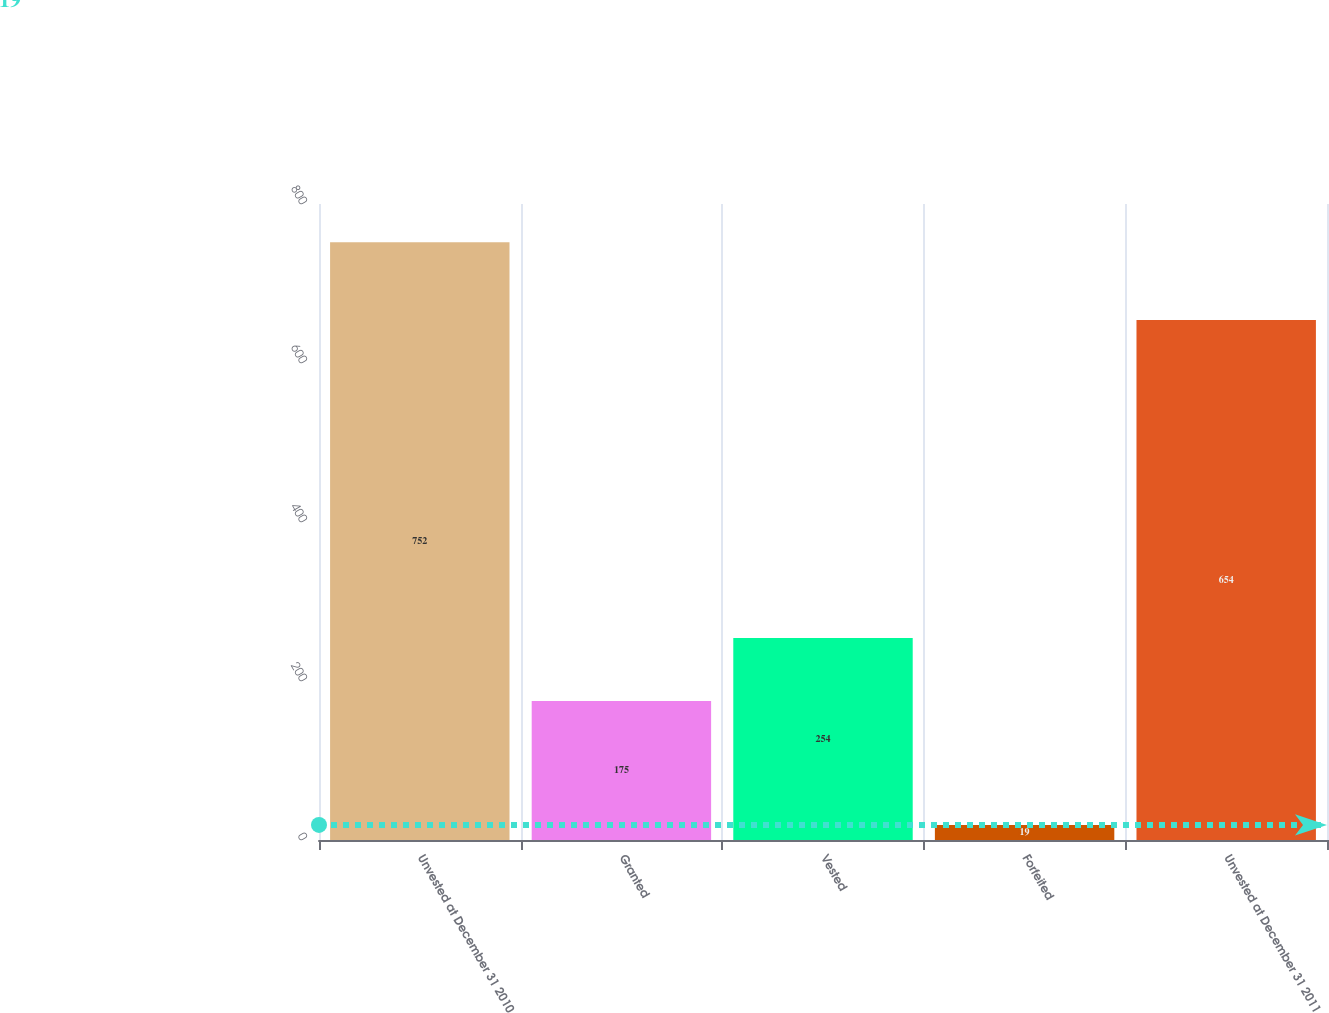<chart> <loc_0><loc_0><loc_500><loc_500><bar_chart><fcel>Unvested at December 31 2010<fcel>Granted<fcel>Vested<fcel>Forfeited<fcel>Unvested at December 31 2011<nl><fcel>752<fcel>175<fcel>254<fcel>19<fcel>654<nl></chart> 